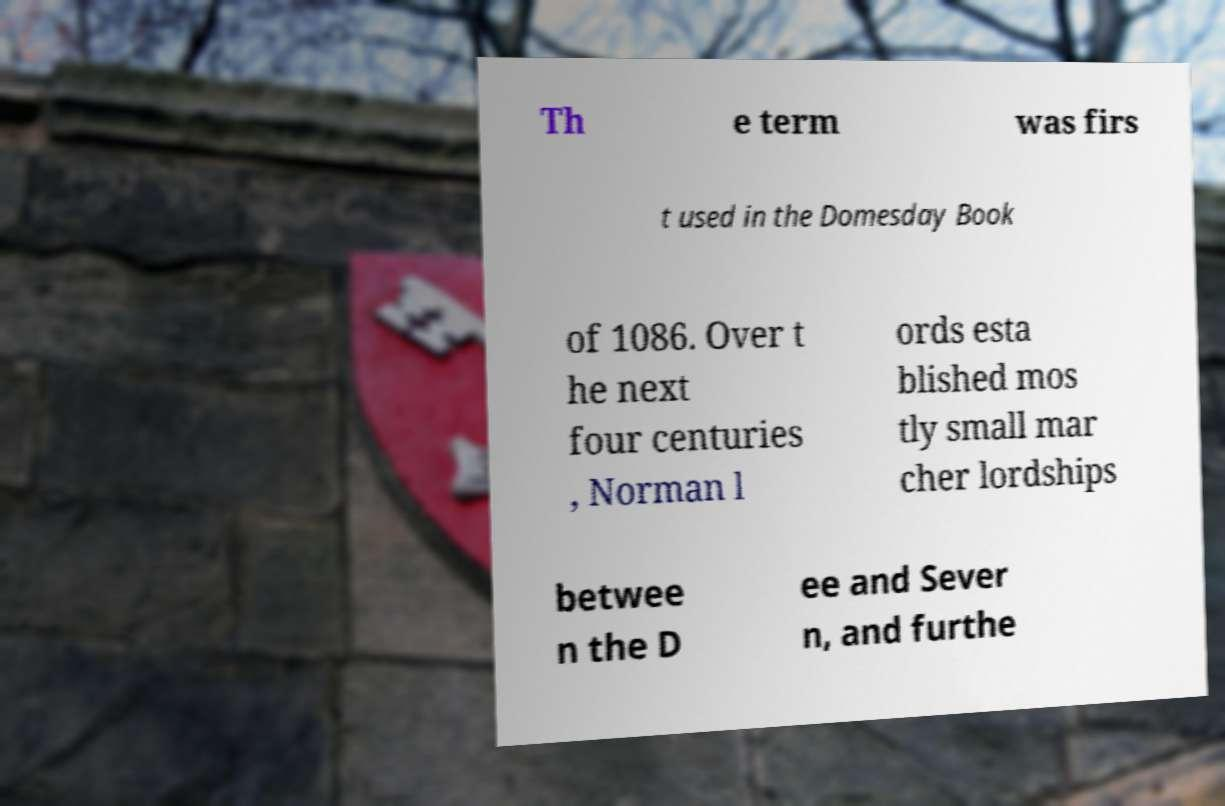What messages or text are displayed in this image? I need them in a readable, typed format. Th e term was firs t used in the Domesday Book of 1086. Over t he next four centuries , Norman l ords esta blished mos tly small mar cher lordships betwee n the D ee and Sever n, and furthe 